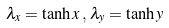Convert formula to latex. <formula><loc_0><loc_0><loc_500><loc_500>\lambda _ { x } = \tanh x \, , \, \lambda _ { y } = \tanh y</formula> 